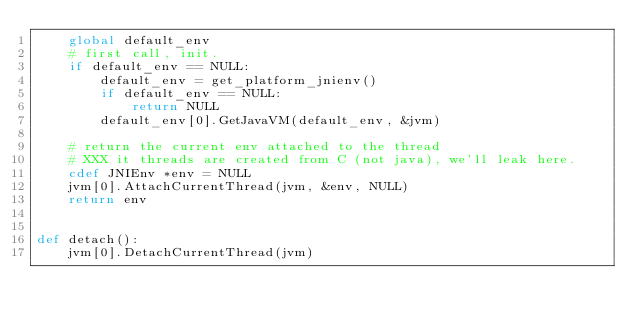<code> <loc_0><loc_0><loc_500><loc_500><_Cython_>    global default_env
    # first call, init.
    if default_env == NULL:
        default_env = get_platform_jnienv()
        if default_env == NULL:
            return NULL
        default_env[0].GetJavaVM(default_env, &jvm)

    # return the current env attached to the thread
    # XXX it threads are created from C (not java), we'll leak here.
    cdef JNIEnv *env = NULL
    jvm[0].AttachCurrentThread(jvm, &env, NULL)
    return env


def detach():
    jvm[0].DetachCurrentThread(jvm)

</code> 